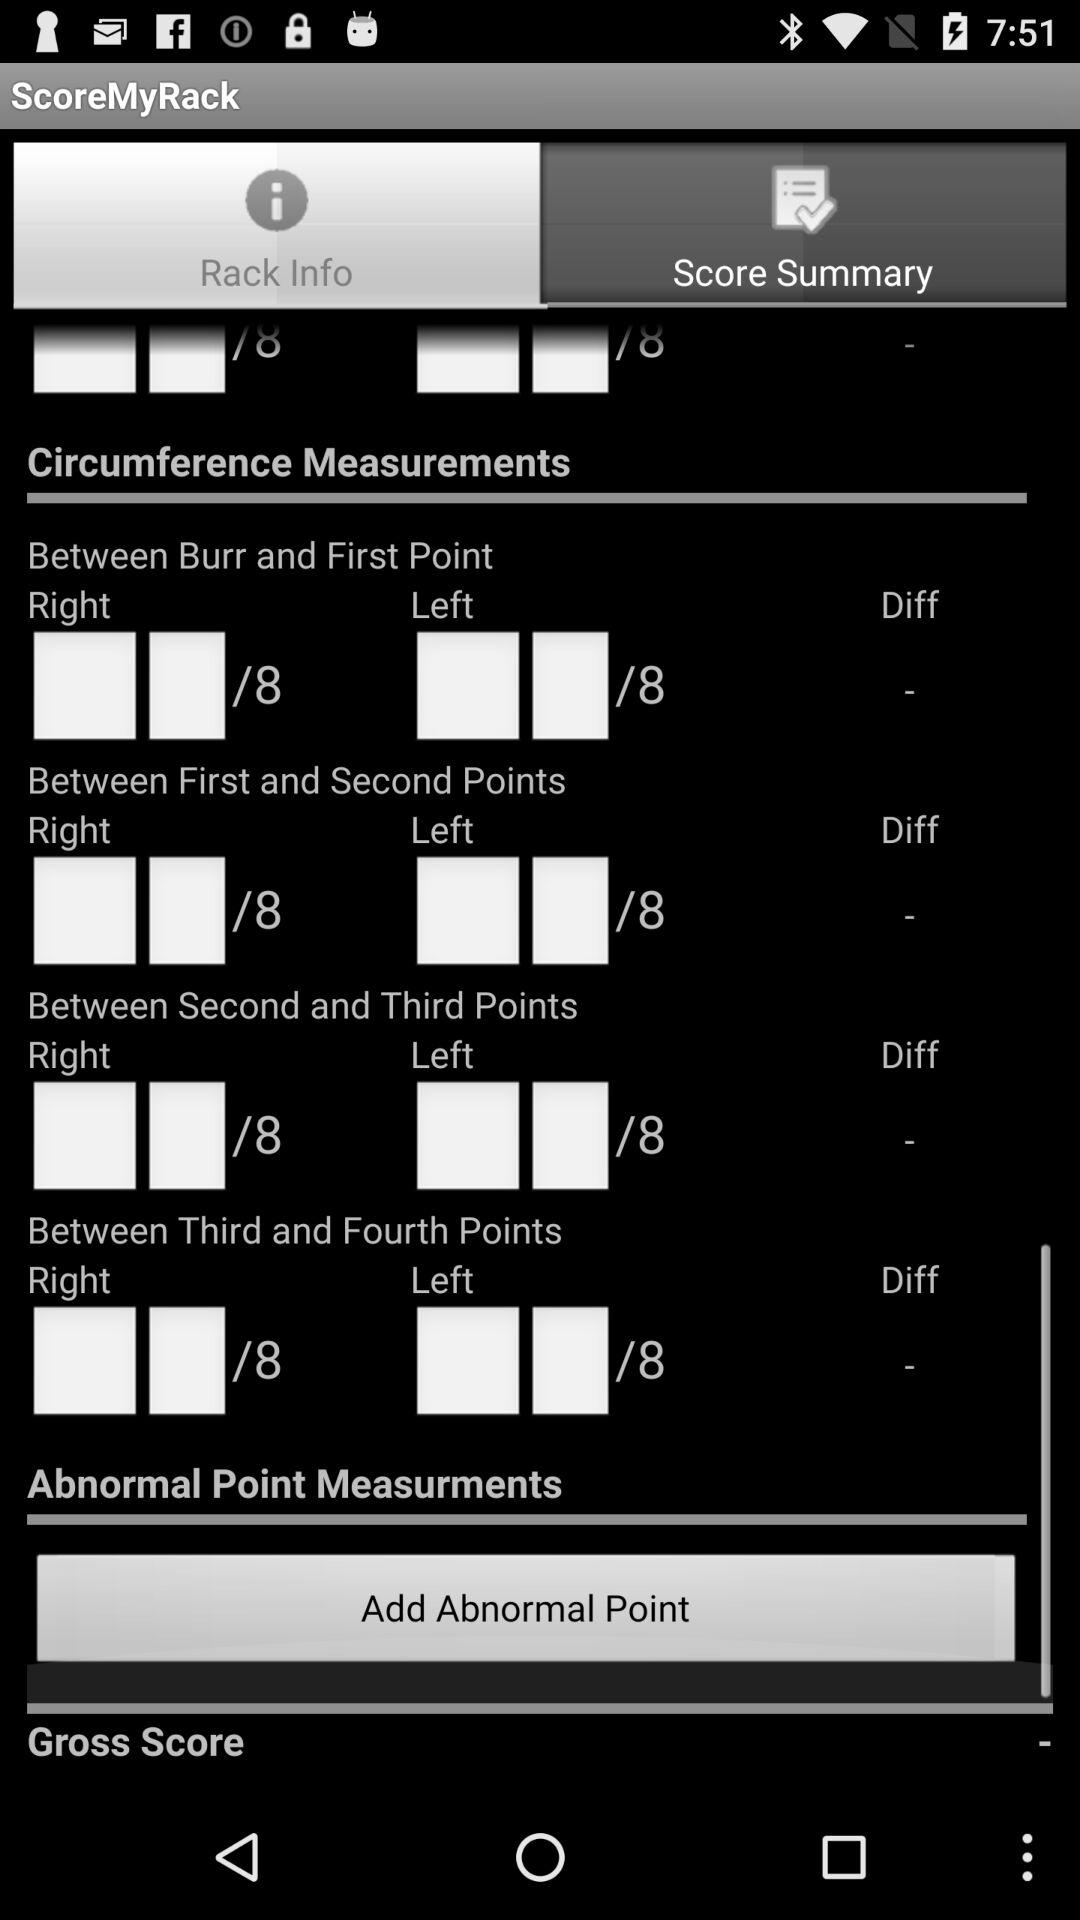Which is the selected option? The selected option is "Rack Info". 